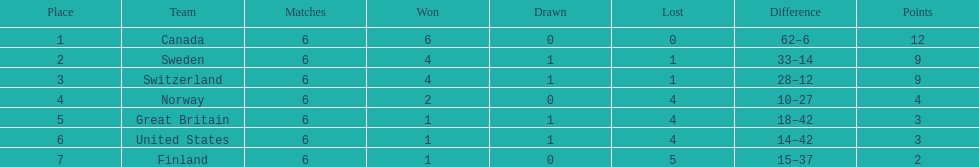Which country finished below the united states? Finland. 